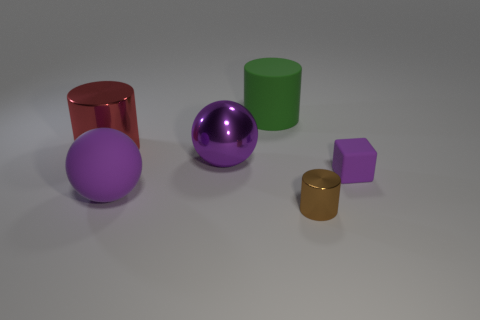Add 2 blocks. How many objects exist? 8 Subtract all cubes. How many objects are left? 5 Add 4 metal cylinders. How many metal cylinders exist? 6 Subtract 0 red cubes. How many objects are left? 6 Subtract all green objects. Subtract all small metal cylinders. How many objects are left? 4 Add 2 large red metal cylinders. How many large red metal cylinders are left? 3 